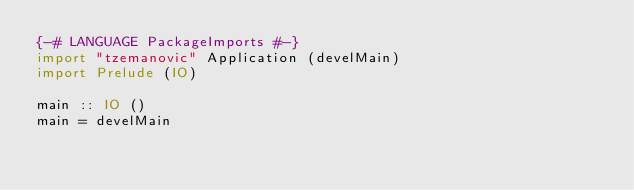<code> <loc_0><loc_0><loc_500><loc_500><_Haskell_>{-# LANGUAGE PackageImports #-}
import "tzemanovic" Application (develMain)
import Prelude (IO)

main :: IO ()
main = develMain
</code> 